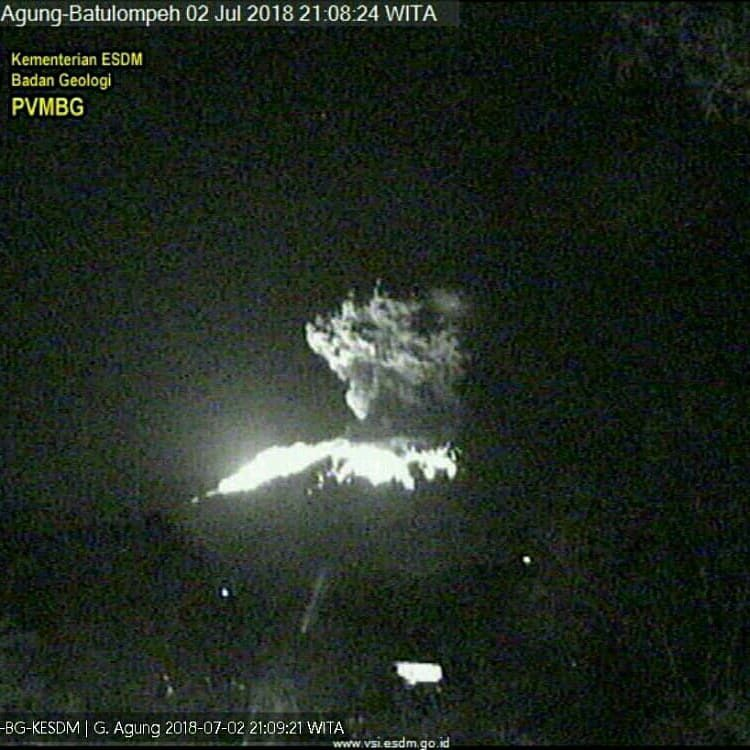How might this eruption affect air travel in the region? Volcanic eruptions can have a significant impact on air travel due to the ash clouds they produce. The ash can cause serious engine failures and pose dangers to aircraft. From the image, it appears that a substantial amount of ash and volcanic gases are being emitted, which could drift into airspace used by commercial airliners. Air traffic controllers in the region would need to reroute flights to avoid these dangerous ash clouds, potentially causing delays and cancellations. The authorities monitor such eruptions closely to ensure the safety of air travel. Can you provide a detailed explanation of how volcanic ash affects aircraft engines? Certainly! Volcanic ash poses a severe threat to aircraft for several reasons. When an aircraft flies through an ash cloud, the ash particles can melt inside the hot temperatures of the engine and then re-solidify on cooler parts, causing blockages and damage. These particles are highly abrasive and can erode the blades and other components of the engine, reducing its efficiency and leading to potential engine failure. Additionally, the ash can clog the fuel system and the air intake, impacting the aircraft's performance and safety. Pilots also face visibility issues because the ash can obscure the windscreen and interfere with navigation systems. Given all these hazards, entering an ash cloud is extremely risky for any aircraft. 